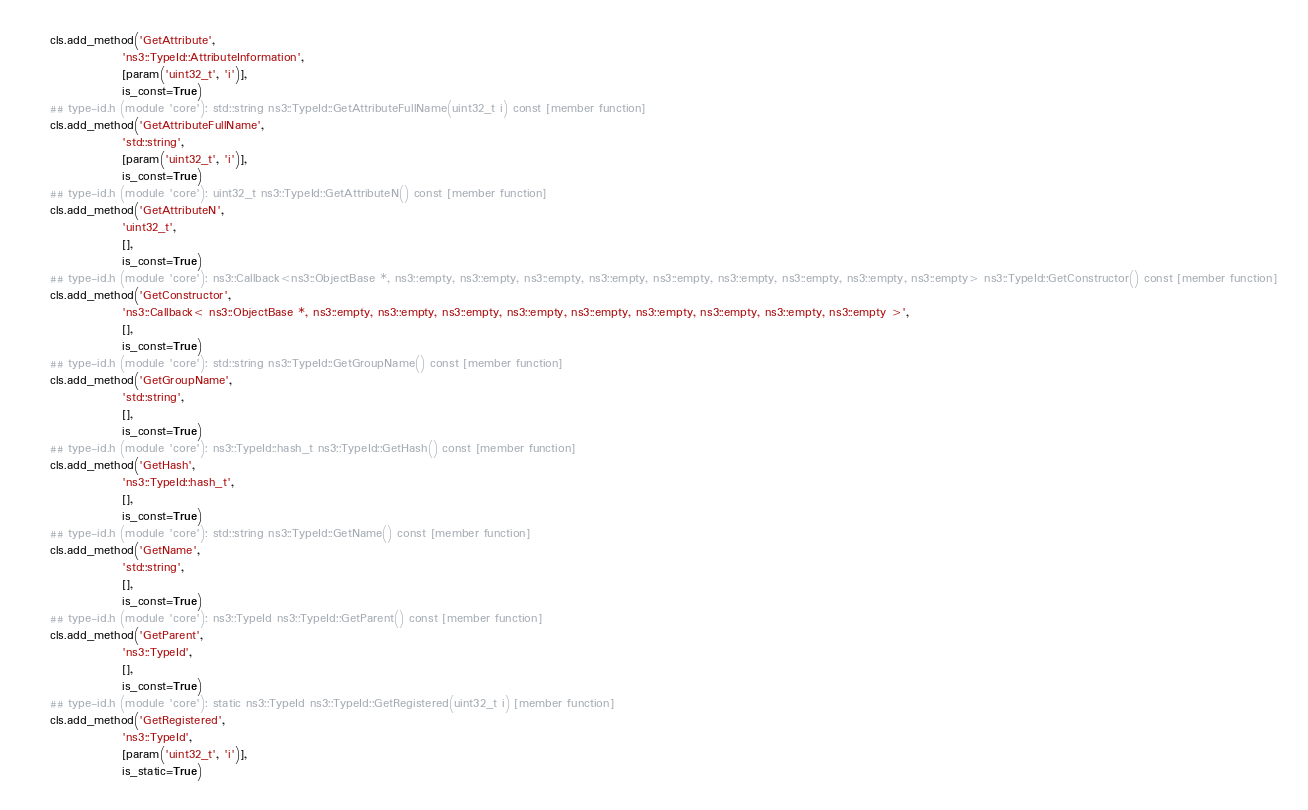<code> <loc_0><loc_0><loc_500><loc_500><_Python_>    cls.add_method('GetAttribute', 
                   'ns3::TypeId::AttributeInformation', 
                   [param('uint32_t', 'i')], 
                   is_const=True)
    ## type-id.h (module 'core'): std::string ns3::TypeId::GetAttributeFullName(uint32_t i) const [member function]
    cls.add_method('GetAttributeFullName', 
                   'std::string', 
                   [param('uint32_t', 'i')], 
                   is_const=True)
    ## type-id.h (module 'core'): uint32_t ns3::TypeId::GetAttributeN() const [member function]
    cls.add_method('GetAttributeN', 
                   'uint32_t', 
                   [], 
                   is_const=True)
    ## type-id.h (module 'core'): ns3::Callback<ns3::ObjectBase *, ns3::empty, ns3::empty, ns3::empty, ns3::empty, ns3::empty, ns3::empty, ns3::empty, ns3::empty, ns3::empty> ns3::TypeId::GetConstructor() const [member function]
    cls.add_method('GetConstructor', 
                   'ns3::Callback< ns3::ObjectBase *, ns3::empty, ns3::empty, ns3::empty, ns3::empty, ns3::empty, ns3::empty, ns3::empty, ns3::empty, ns3::empty >', 
                   [], 
                   is_const=True)
    ## type-id.h (module 'core'): std::string ns3::TypeId::GetGroupName() const [member function]
    cls.add_method('GetGroupName', 
                   'std::string', 
                   [], 
                   is_const=True)
    ## type-id.h (module 'core'): ns3::TypeId::hash_t ns3::TypeId::GetHash() const [member function]
    cls.add_method('GetHash', 
                   'ns3::TypeId::hash_t', 
                   [], 
                   is_const=True)
    ## type-id.h (module 'core'): std::string ns3::TypeId::GetName() const [member function]
    cls.add_method('GetName', 
                   'std::string', 
                   [], 
                   is_const=True)
    ## type-id.h (module 'core'): ns3::TypeId ns3::TypeId::GetParent() const [member function]
    cls.add_method('GetParent', 
                   'ns3::TypeId', 
                   [], 
                   is_const=True)
    ## type-id.h (module 'core'): static ns3::TypeId ns3::TypeId::GetRegistered(uint32_t i) [member function]
    cls.add_method('GetRegistered', 
                   'ns3::TypeId', 
                   [param('uint32_t', 'i')], 
                   is_static=True)</code> 